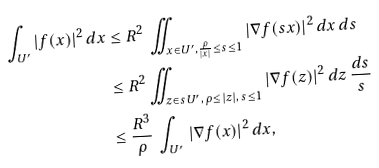Convert formula to latex. <formula><loc_0><loc_0><loc_500><loc_500>\int _ { U ^ { \prime } } | f ( x ) | ^ { 2 } \, d x & \leq R ^ { 2 } \, \iint _ { x \in U ^ { \prime } , { \frac { \rho } { | x | } } \leq s \leq 1 } | \nabla f ( s x ) | ^ { 2 } \, d x \, d s \\ & \leq R ^ { 2 } \iint _ { z \in s U ^ { \prime } , \, { \rho \leq | z | } , \, s \leq 1 } | \nabla f ( z ) | ^ { 2 } \, d z \, { \frac { d s } { s } } \\ & \leq \frac { R ^ { 3 } } { \rho } \, \int _ { U ^ { \prime } } \, | \nabla f ( x ) | ^ { 2 } \, d x , \\</formula> 